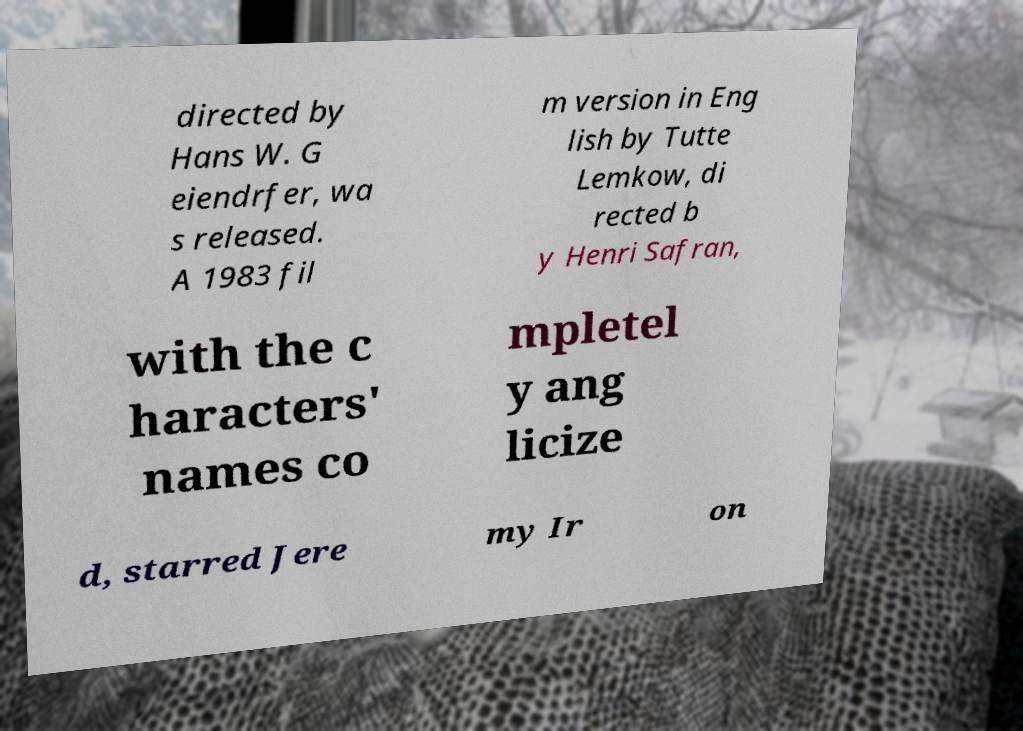Can you accurately transcribe the text from the provided image for me? directed by Hans W. G eiendrfer, wa s released. A 1983 fil m version in Eng lish by Tutte Lemkow, di rected b y Henri Safran, with the c haracters' names co mpletel y ang licize d, starred Jere my Ir on 